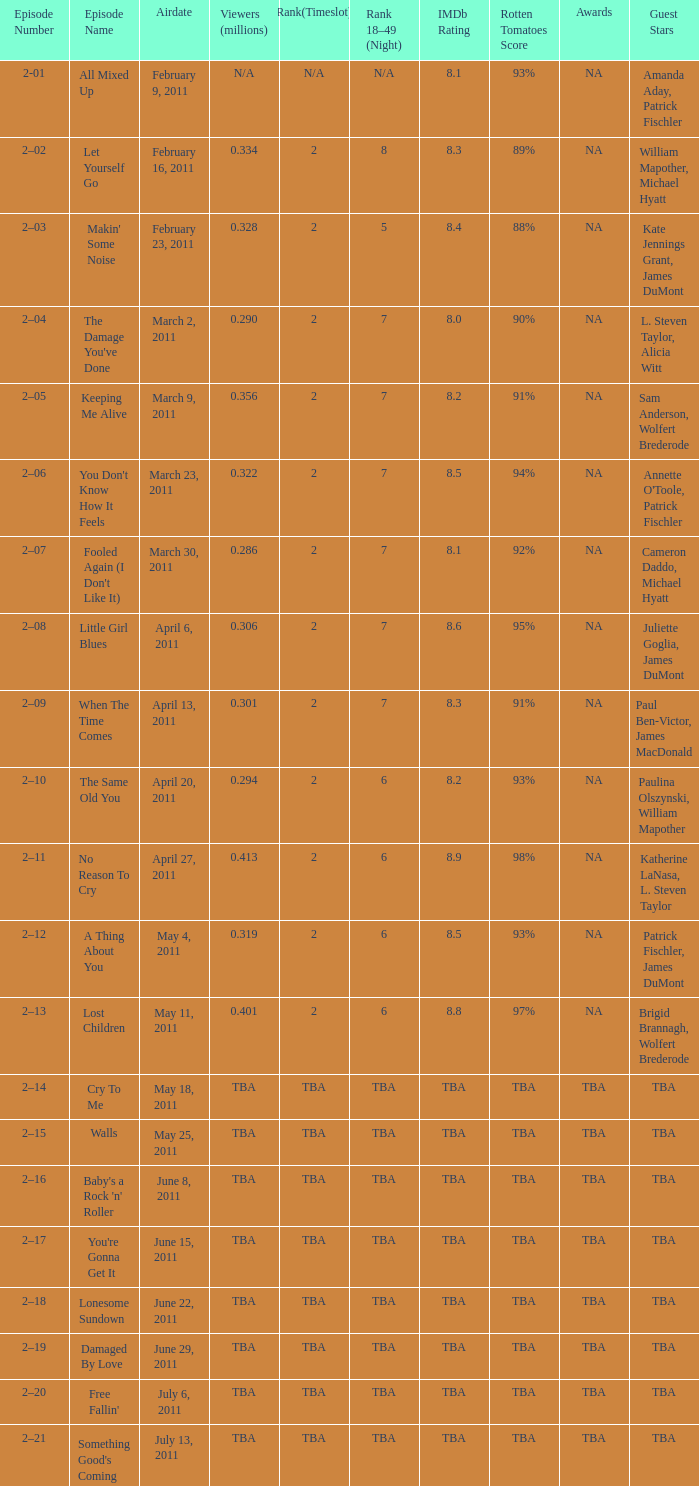What is the total rank on airdate march 30, 2011? 1.0. 